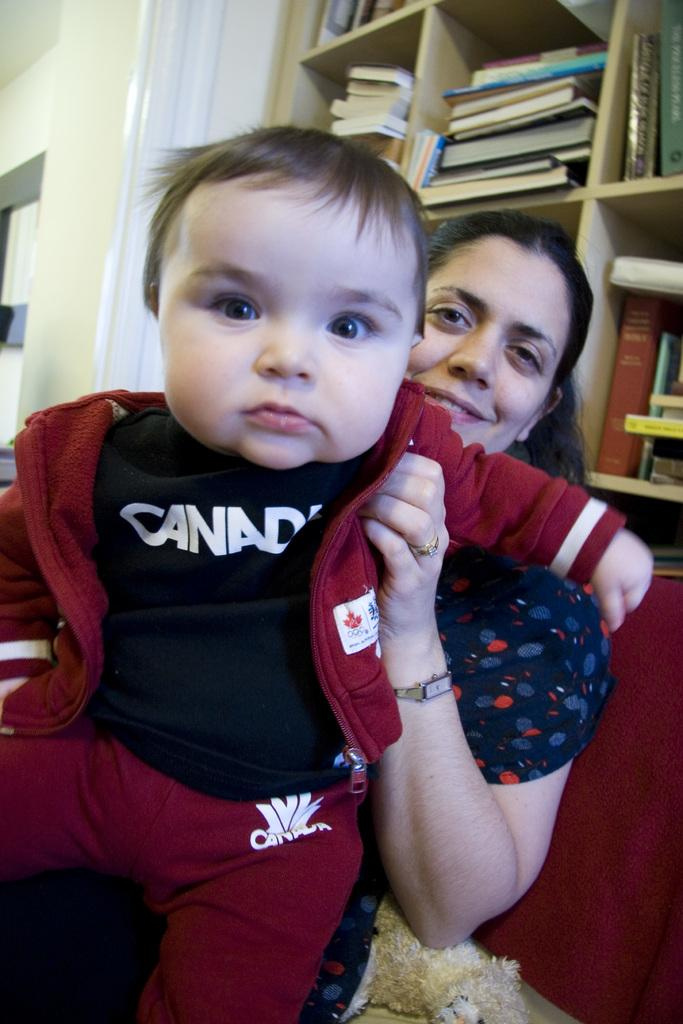Who is present in the image? There is a woman in the image. What is the woman doing in the image? The woman is sitting on a sofa and holding a kid. What can be seen in the background of the image? There are racks in the background of the image. What is on the racks? There are books on the racks. What type of bird can be seen flying in the image? There is no bird present in the image. What is the woman using to sew in the image? The woman is not using a needle or sewing in the image; she is holding a kid. 